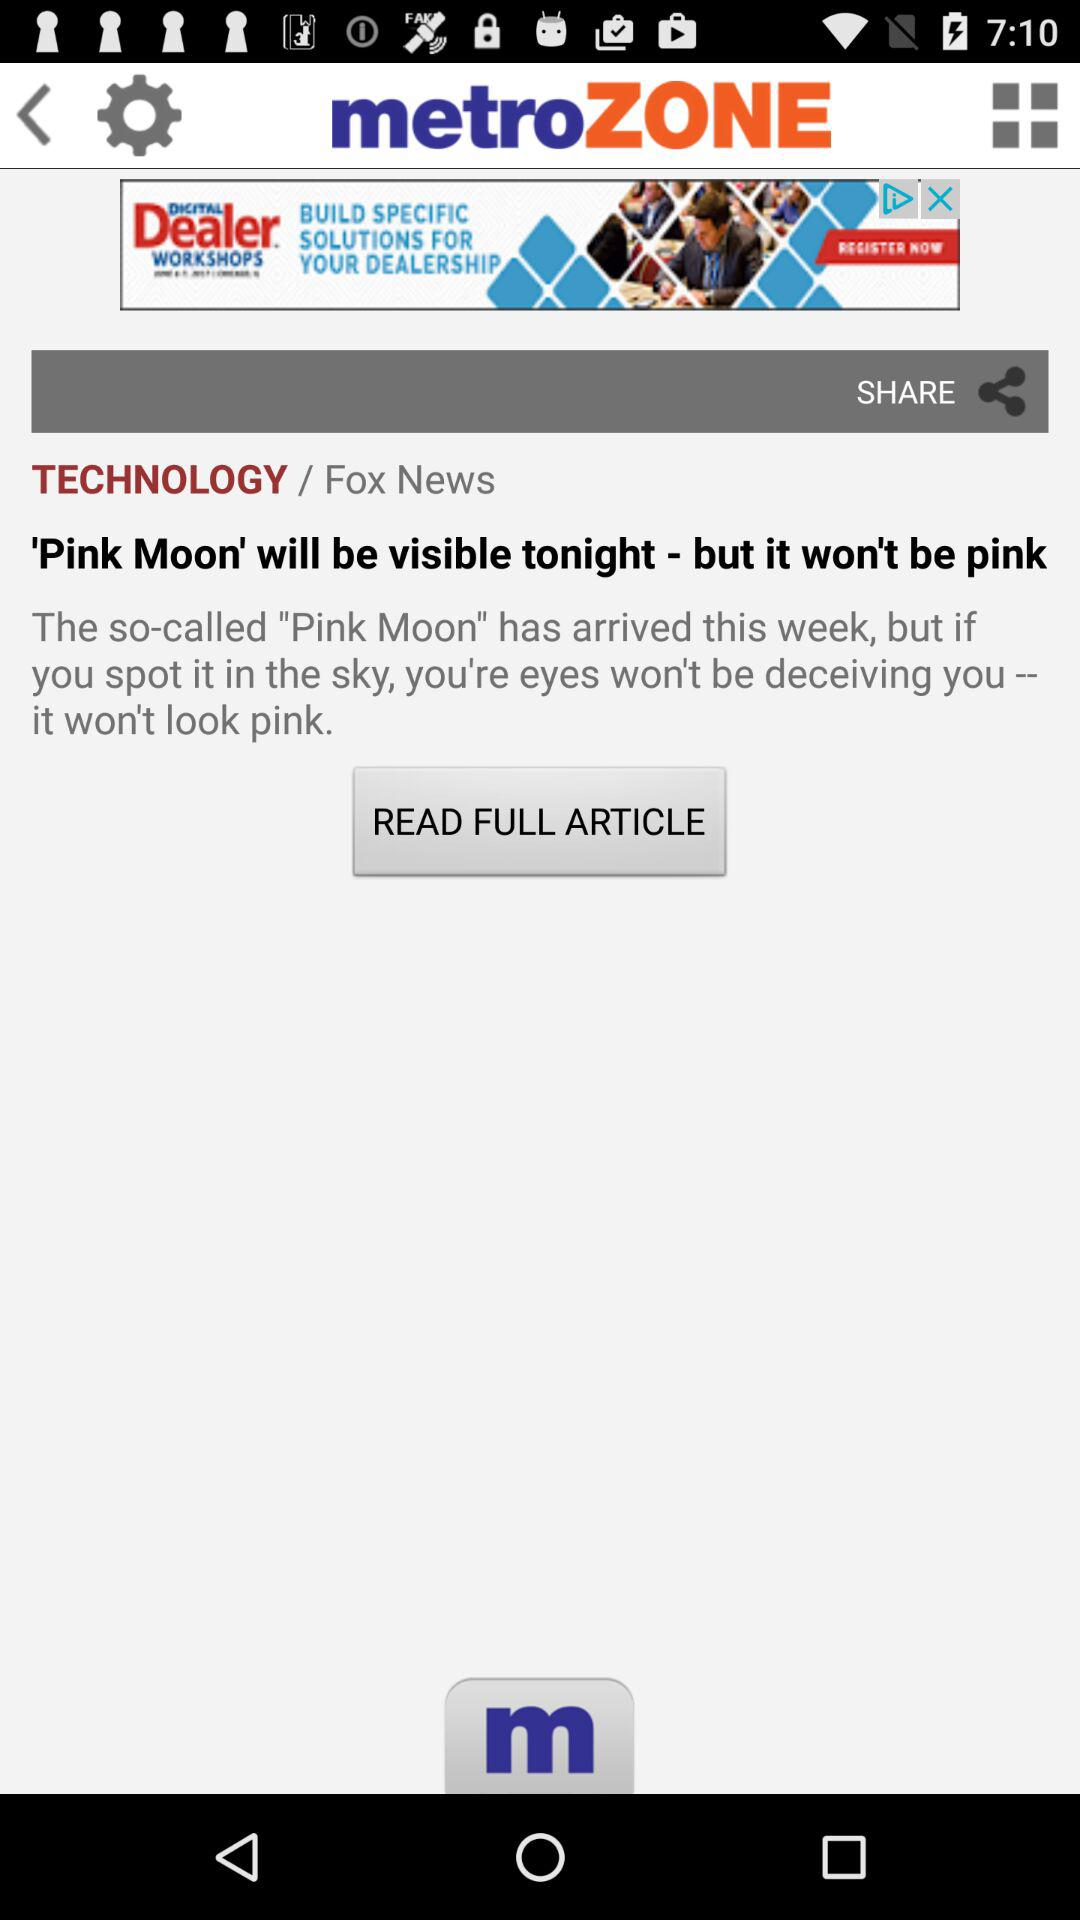What is the application name? The application name is "metroZONE". 